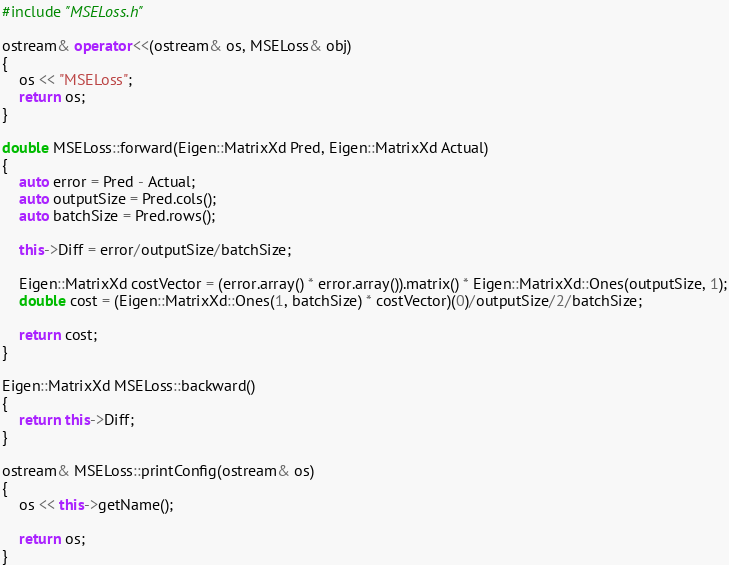Convert code to text. <code><loc_0><loc_0><loc_500><loc_500><_C++_>#include "MSELoss.h"

ostream& operator<<(ostream& os, MSELoss& obj)
{
    os << "MSELoss";
    return os;
}

double MSELoss::forward(Eigen::MatrixXd Pred, Eigen::MatrixXd Actual)
{
    auto error = Pred - Actual;
    auto outputSize = Pred.cols();
    auto batchSize = Pred.rows();

    this->Diff = error/outputSize/batchSize;

    Eigen::MatrixXd costVector = (error.array() * error.array()).matrix() * Eigen::MatrixXd::Ones(outputSize, 1);
    double cost = (Eigen::MatrixXd::Ones(1, batchSize) * costVector)(0)/outputSize/2/batchSize;

    return cost;
}

Eigen::MatrixXd MSELoss::backward()
{
    return this->Diff;
}

ostream& MSELoss::printConfig(ostream& os)
{
    os << this->getName();

    return os;
}
</code> 